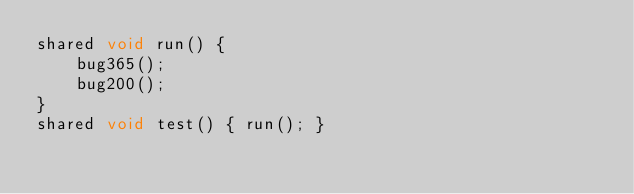<code> <loc_0><loc_0><loc_500><loc_500><_Ceylon_>shared void run() {
    bug365();
    bug200();
}
shared void test() { run(); }
</code> 